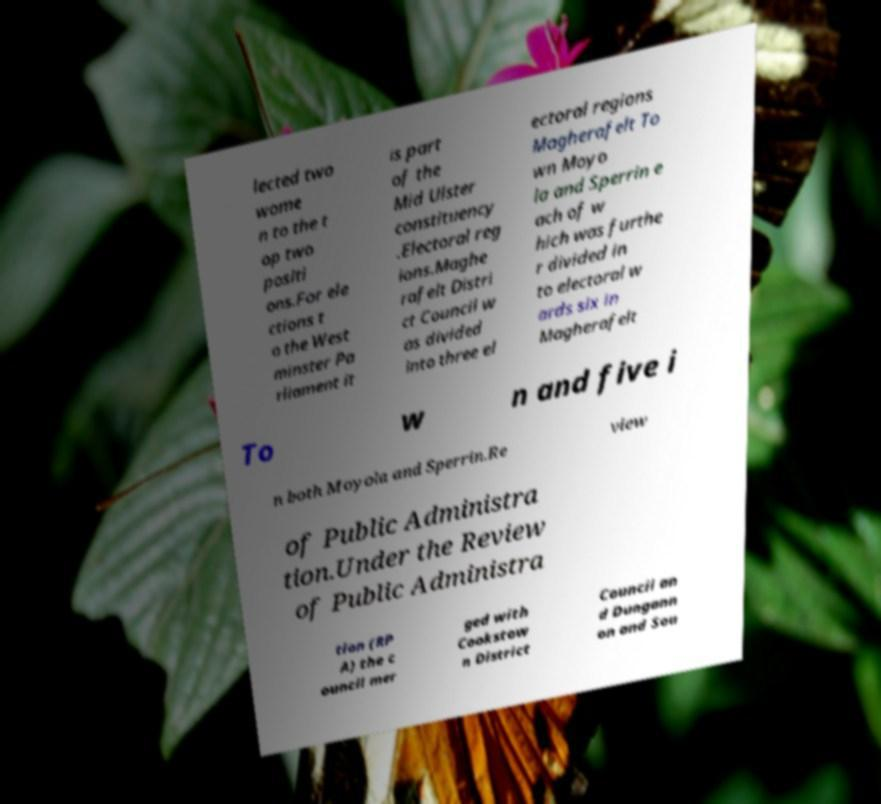What messages or text are displayed in this image? I need them in a readable, typed format. lected two wome n to the t op two positi ons.For ele ctions t o the West minster Pa rliament it is part of the Mid Ulster constituency .Electoral reg ions.Maghe rafelt Distri ct Council w as divided into three el ectoral regions Magherafelt To wn Moyo la and Sperrin e ach of w hich was furthe r divided in to electoral w ards six in Magherafelt To w n and five i n both Moyola and Sperrin.Re view of Public Administra tion.Under the Review of Public Administra tion (RP A) the c ouncil mer ged with Cookstow n District Council an d Dungann on and Sou 